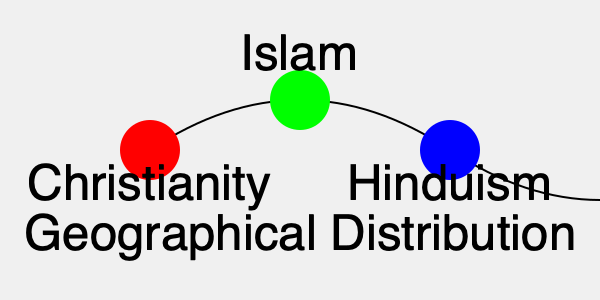Analyzing the color-coded world map of major religions, which faith tradition is represented by the green circle and shows a significant presence in North Africa, the Middle East, and parts of Southeast Asia? To answer this question, we need to examine the color-coded world map and understand the geographical distribution of major world religions:

1. The map shows three colored circles representing major world religions:
   - Red circle: Christianity
   - Green circle: Islam
   - Blue circle: Hinduism

2. The question asks about the faith tradition represented by the green circle.

3. We know that Islam has a significant presence in:
   - North Africa (e.g., Morocco, Algeria, Egypt)
   - The Middle East (e.g., Saudi Arabia, Iran, Iraq)
   - Parts of Southeast Asia (e.g., Indonesia, Malaysia)

4. This geographical distribution aligns with the historical spread of Islam from its birthplace in the Arabian Peninsula.

5. The green circle in the map represents Islam, which corresponds to the regions mentioned in the question.

Therefore, the faith tradition represented by the green circle and showing a significant presence in the specified regions is Islam.
Answer: Islam 